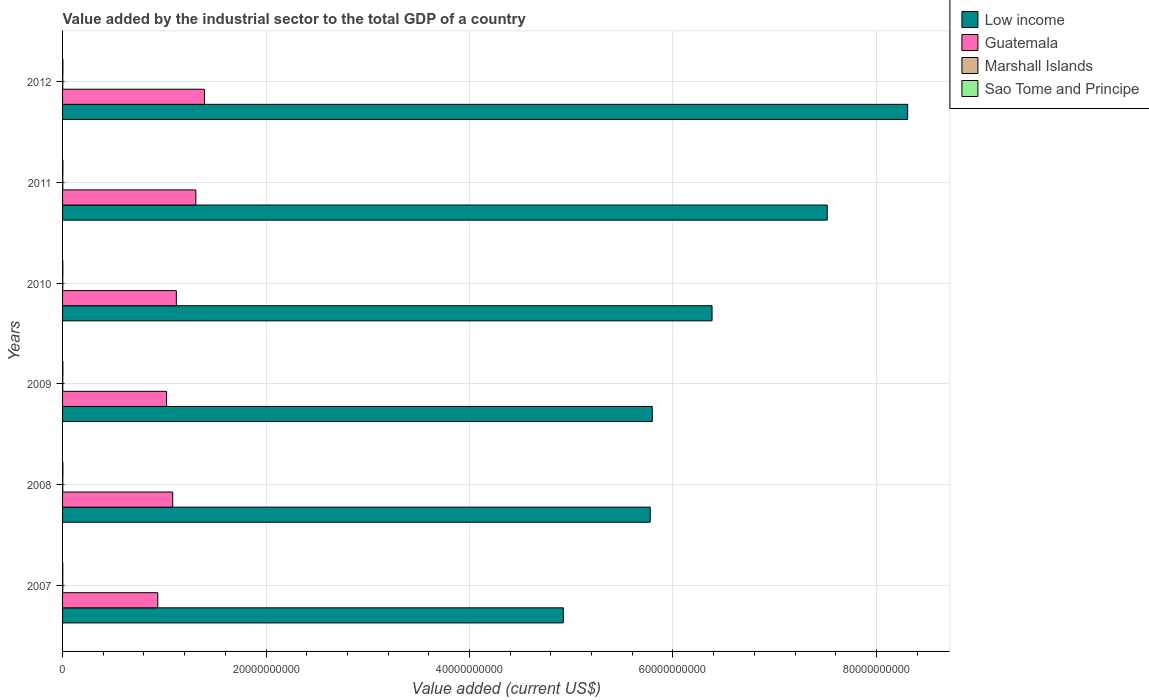How many groups of bars are there?
Your response must be concise. 6. Are the number of bars on each tick of the Y-axis equal?
Give a very brief answer. Yes. What is the label of the 6th group of bars from the top?
Offer a very short reply. 2007. In how many cases, is the number of bars for a given year not equal to the number of legend labels?
Your answer should be compact. 0. What is the value added by the industrial sector to the total GDP in Guatemala in 2007?
Make the answer very short. 9.36e+09. Across all years, what is the maximum value added by the industrial sector to the total GDP in Low income?
Your response must be concise. 8.31e+1. Across all years, what is the minimum value added by the industrial sector to the total GDP in Guatemala?
Provide a short and direct response. 9.36e+09. What is the total value added by the industrial sector to the total GDP in Marshall Islands in the graph?
Provide a succinct answer. 1.15e+08. What is the difference between the value added by the industrial sector to the total GDP in Low income in 2010 and that in 2011?
Make the answer very short. -1.13e+1. What is the difference between the value added by the industrial sector to the total GDP in Sao Tome and Principe in 2009 and the value added by the industrial sector to the total GDP in Marshall Islands in 2007?
Your answer should be compact. 1.25e+07. What is the average value added by the industrial sector to the total GDP in Low income per year?
Your response must be concise. 6.45e+1. In the year 2011, what is the difference between the value added by the industrial sector to the total GDP in Low income and value added by the industrial sector to the total GDP in Guatemala?
Ensure brevity in your answer.  6.21e+1. What is the ratio of the value added by the industrial sector to the total GDP in Marshall Islands in 2009 to that in 2011?
Your answer should be compact. 0.82. Is the value added by the industrial sector to the total GDP in Guatemala in 2008 less than that in 2009?
Your answer should be compact. No. What is the difference between the highest and the second highest value added by the industrial sector to the total GDP in Marshall Islands?
Offer a terse response. 1.68e+06. What is the difference between the highest and the lowest value added by the industrial sector to the total GDP in Marshall Islands?
Your answer should be very brief. 3.79e+06. What does the 1st bar from the top in 2009 represents?
Your answer should be compact. Sao Tome and Principe. Is it the case that in every year, the sum of the value added by the industrial sector to the total GDP in Marshall Islands and value added by the industrial sector to the total GDP in Low income is greater than the value added by the industrial sector to the total GDP in Guatemala?
Keep it short and to the point. Yes. How many bars are there?
Ensure brevity in your answer.  24. Are all the bars in the graph horizontal?
Provide a succinct answer. Yes. How many years are there in the graph?
Ensure brevity in your answer.  6. Does the graph contain any zero values?
Your response must be concise. No. Does the graph contain grids?
Your answer should be very brief. Yes. Where does the legend appear in the graph?
Offer a terse response. Top right. What is the title of the graph?
Make the answer very short. Value added by the industrial sector to the total GDP of a country. Does "Syrian Arab Republic" appear as one of the legend labels in the graph?
Your response must be concise. No. What is the label or title of the X-axis?
Give a very brief answer. Value added (current US$). What is the label or title of the Y-axis?
Give a very brief answer. Years. What is the Value added (current US$) in Low income in 2007?
Keep it short and to the point. 4.92e+1. What is the Value added (current US$) of Guatemala in 2007?
Ensure brevity in your answer.  9.36e+09. What is the Value added (current US$) of Marshall Islands in 2007?
Your response must be concise. 1.90e+07. What is the Value added (current US$) of Sao Tome and Principe in 2007?
Keep it short and to the point. 2.17e+07. What is the Value added (current US$) of Low income in 2008?
Ensure brevity in your answer.  5.78e+1. What is the Value added (current US$) of Guatemala in 2008?
Offer a terse response. 1.08e+1. What is the Value added (current US$) in Marshall Islands in 2008?
Your answer should be very brief. 1.95e+07. What is the Value added (current US$) of Sao Tome and Principe in 2008?
Your response must be concise. 3.22e+07. What is the Value added (current US$) in Low income in 2009?
Provide a succinct answer. 5.80e+1. What is the Value added (current US$) of Guatemala in 2009?
Make the answer very short. 1.02e+1. What is the Value added (current US$) in Marshall Islands in 2009?
Provide a short and direct response. 1.76e+07. What is the Value added (current US$) in Sao Tome and Principe in 2009?
Your answer should be very brief. 3.15e+07. What is the Value added (current US$) in Low income in 2010?
Your answer should be very brief. 6.38e+1. What is the Value added (current US$) in Guatemala in 2010?
Offer a very short reply. 1.12e+1. What is the Value added (current US$) in Marshall Islands in 2010?
Provide a succinct answer. 1.83e+07. What is the Value added (current US$) of Sao Tome and Principe in 2010?
Give a very brief answer. 2.71e+07. What is the Value added (current US$) of Low income in 2011?
Offer a very short reply. 7.52e+1. What is the Value added (current US$) of Guatemala in 2011?
Make the answer very short. 1.31e+1. What is the Value added (current US$) in Marshall Islands in 2011?
Offer a terse response. 2.13e+07. What is the Value added (current US$) of Sao Tome and Principe in 2011?
Make the answer very short. 3.18e+07. What is the Value added (current US$) in Low income in 2012?
Offer a very short reply. 8.31e+1. What is the Value added (current US$) in Guatemala in 2012?
Offer a terse response. 1.39e+1. What is the Value added (current US$) of Marshall Islands in 2012?
Offer a terse response. 1.97e+07. What is the Value added (current US$) in Sao Tome and Principe in 2012?
Offer a terse response. 3.20e+07. Across all years, what is the maximum Value added (current US$) in Low income?
Your answer should be compact. 8.31e+1. Across all years, what is the maximum Value added (current US$) in Guatemala?
Your answer should be compact. 1.39e+1. Across all years, what is the maximum Value added (current US$) in Marshall Islands?
Provide a short and direct response. 2.13e+07. Across all years, what is the maximum Value added (current US$) of Sao Tome and Principe?
Keep it short and to the point. 3.22e+07. Across all years, what is the minimum Value added (current US$) of Low income?
Your answer should be very brief. 4.92e+1. Across all years, what is the minimum Value added (current US$) in Guatemala?
Give a very brief answer. 9.36e+09. Across all years, what is the minimum Value added (current US$) of Marshall Islands?
Your answer should be very brief. 1.76e+07. Across all years, what is the minimum Value added (current US$) of Sao Tome and Principe?
Offer a very short reply. 2.17e+07. What is the total Value added (current US$) of Low income in the graph?
Provide a succinct answer. 3.87e+11. What is the total Value added (current US$) in Guatemala in the graph?
Ensure brevity in your answer.  6.86e+1. What is the total Value added (current US$) of Marshall Islands in the graph?
Give a very brief answer. 1.15e+08. What is the total Value added (current US$) in Sao Tome and Principe in the graph?
Your answer should be compact. 1.76e+08. What is the difference between the Value added (current US$) of Low income in 2007 and that in 2008?
Ensure brevity in your answer.  -8.54e+09. What is the difference between the Value added (current US$) in Guatemala in 2007 and that in 2008?
Give a very brief answer. -1.47e+09. What is the difference between the Value added (current US$) in Marshall Islands in 2007 and that in 2008?
Give a very brief answer. -4.33e+05. What is the difference between the Value added (current US$) in Sao Tome and Principe in 2007 and that in 2008?
Keep it short and to the point. -1.04e+07. What is the difference between the Value added (current US$) of Low income in 2007 and that in 2009?
Make the answer very short. -8.74e+09. What is the difference between the Value added (current US$) of Guatemala in 2007 and that in 2009?
Ensure brevity in your answer.  -8.59e+08. What is the difference between the Value added (current US$) of Marshall Islands in 2007 and that in 2009?
Provide a short and direct response. 1.47e+06. What is the difference between the Value added (current US$) in Sao Tome and Principe in 2007 and that in 2009?
Your answer should be very brief. -9.80e+06. What is the difference between the Value added (current US$) in Low income in 2007 and that in 2010?
Offer a terse response. -1.46e+1. What is the difference between the Value added (current US$) in Guatemala in 2007 and that in 2010?
Give a very brief answer. -1.82e+09. What is the difference between the Value added (current US$) in Marshall Islands in 2007 and that in 2010?
Make the answer very short. 7.64e+05. What is the difference between the Value added (current US$) in Sao Tome and Principe in 2007 and that in 2010?
Your response must be concise. -5.40e+06. What is the difference between the Value added (current US$) of Low income in 2007 and that in 2011?
Keep it short and to the point. -2.59e+1. What is the difference between the Value added (current US$) of Guatemala in 2007 and that in 2011?
Provide a succinct answer. -3.74e+09. What is the difference between the Value added (current US$) in Marshall Islands in 2007 and that in 2011?
Offer a very short reply. -2.33e+06. What is the difference between the Value added (current US$) in Sao Tome and Principe in 2007 and that in 2011?
Provide a short and direct response. -1.01e+07. What is the difference between the Value added (current US$) of Low income in 2007 and that in 2012?
Keep it short and to the point. -3.38e+1. What is the difference between the Value added (current US$) in Guatemala in 2007 and that in 2012?
Keep it short and to the point. -4.59e+09. What is the difference between the Value added (current US$) in Marshall Islands in 2007 and that in 2012?
Provide a short and direct response. -6.45e+05. What is the difference between the Value added (current US$) in Sao Tome and Principe in 2007 and that in 2012?
Provide a short and direct response. -1.03e+07. What is the difference between the Value added (current US$) of Low income in 2008 and that in 2009?
Provide a succinct answer. -2.02e+08. What is the difference between the Value added (current US$) in Guatemala in 2008 and that in 2009?
Offer a terse response. 6.07e+08. What is the difference between the Value added (current US$) of Marshall Islands in 2008 and that in 2009?
Your answer should be very brief. 1.90e+06. What is the difference between the Value added (current US$) of Sao Tome and Principe in 2008 and that in 2009?
Offer a very short reply. 6.39e+05. What is the difference between the Value added (current US$) in Low income in 2008 and that in 2010?
Your response must be concise. -6.08e+09. What is the difference between the Value added (current US$) of Guatemala in 2008 and that in 2010?
Your answer should be very brief. -3.57e+08. What is the difference between the Value added (current US$) in Marshall Islands in 2008 and that in 2010?
Ensure brevity in your answer.  1.20e+06. What is the difference between the Value added (current US$) in Sao Tome and Principe in 2008 and that in 2010?
Give a very brief answer. 5.04e+06. What is the difference between the Value added (current US$) of Low income in 2008 and that in 2011?
Ensure brevity in your answer.  -1.74e+1. What is the difference between the Value added (current US$) of Guatemala in 2008 and that in 2011?
Provide a short and direct response. -2.27e+09. What is the difference between the Value added (current US$) of Marshall Islands in 2008 and that in 2011?
Your answer should be compact. -1.89e+06. What is the difference between the Value added (current US$) in Sao Tome and Principe in 2008 and that in 2011?
Make the answer very short. 3.62e+05. What is the difference between the Value added (current US$) of Low income in 2008 and that in 2012?
Offer a very short reply. -2.53e+1. What is the difference between the Value added (current US$) in Guatemala in 2008 and that in 2012?
Your response must be concise. -3.12e+09. What is the difference between the Value added (current US$) in Marshall Islands in 2008 and that in 2012?
Keep it short and to the point. -2.12e+05. What is the difference between the Value added (current US$) of Sao Tome and Principe in 2008 and that in 2012?
Your answer should be compact. 1.68e+05. What is the difference between the Value added (current US$) of Low income in 2009 and that in 2010?
Give a very brief answer. -5.88e+09. What is the difference between the Value added (current US$) of Guatemala in 2009 and that in 2010?
Provide a short and direct response. -9.63e+08. What is the difference between the Value added (current US$) in Marshall Islands in 2009 and that in 2010?
Offer a terse response. -7.02e+05. What is the difference between the Value added (current US$) in Sao Tome and Principe in 2009 and that in 2010?
Your response must be concise. 4.40e+06. What is the difference between the Value added (current US$) of Low income in 2009 and that in 2011?
Provide a succinct answer. -1.72e+1. What is the difference between the Value added (current US$) of Guatemala in 2009 and that in 2011?
Give a very brief answer. -2.88e+09. What is the difference between the Value added (current US$) of Marshall Islands in 2009 and that in 2011?
Give a very brief answer. -3.79e+06. What is the difference between the Value added (current US$) in Sao Tome and Principe in 2009 and that in 2011?
Your answer should be very brief. -2.76e+05. What is the difference between the Value added (current US$) in Low income in 2009 and that in 2012?
Provide a succinct answer. -2.51e+1. What is the difference between the Value added (current US$) of Guatemala in 2009 and that in 2012?
Keep it short and to the point. -3.73e+09. What is the difference between the Value added (current US$) in Marshall Islands in 2009 and that in 2012?
Your answer should be very brief. -2.11e+06. What is the difference between the Value added (current US$) in Sao Tome and Principe in 2009 and that in 2012?
Ensure brevity in your answer.  -4.70e+05. What is the difference between the Value added (current US$) in Low income in 2010 and that in 2011?
Offer a very short reply. -1.13e+1. What is the difference between the Value added (current US$) of Guatemala in 2010 and that in 2011?
Give a very brief answer. -1.92e+09. What is the difference between the Value added (current US$) in Marshall Islands in 2010 and that in 2011?
Offer a very short reply. -3.09e+06. What is the difference between the Value added (current US$) in Sao Tome and Principe in 2010 and that in 2011?
Make the answer very short. -4.68e+06. What is the difference between the Value added (current US$) of Low income in 2010 and that in 2012?
Your response must be concise. -1.92e+1. What is the difference between the Value added (current US$) of Guatemala in 2010 and that in 2012?
Offer a very short reply. -2.76e+09. What is the difference between the Value added (current US$) in Marshall Islands in 2010 and that in 2012?
Offer a terse response. -1.41e+06. What is the difference between the Value added (current US$) of Sao Tome and Principe in 2010 and that in 2012?
Your response must be concise. -4.87e+06. What is the difference between the Value added (current US$) of Low income in 2011 and that in 2012?
Your answer should be compact. -7.90e+09. What is the difference between the Value added (current US$) in Guatemala in 2011 and that in 2012?
Keep it short and to the point. -8.49e+08. What is the difference between the Value added (current US$) in Marshall Islands in 2011 and that in 2012?
Give a very brief answer. 1.68e+06. What is the difference between the Value added (current US$) in Sao Tome and Principe in 2011 and that in 2012?
Make the answer very short. -1.94e+05. What is the difference between the Value added (current US$) in Low income in 2007 and the Value added (current US$) in Guatemala in 2008?
Your response must be concise. 3.84e+1. What is the difference between the Value added (current US$) in Low income in 2007 and the Value added (current US$) in Marshall Islands in 2008?
Make the answer very short. 4.92e+1. What is the difference between the Value added (current US$) of Low income in 2007 and the Value added (current US$) of Sao Tome and Principe in 2008?
Provide a succinct answer. 4.92e+1. What is the difference between the Value added (current US$) in Guatemala in 2007 and the Value added (current US$) in Marshall Islands in 2008?
Provide a short and direct response. 9.34e+09. What is the difference between the Value added (current US$) of Guatemala in 2007 and the Value added (current US$) of Sao Tome and Principe in 2008?
Offer a terse response. 9.33e+09. What is the difference between the Value added (current US$) in Marshall Islands in 2007 and the Value added (current US$) in Sao Tome and Principe in 2008?
Offer a very short reply. -1.32e+07. What is the difference between the Value added (current US$) of Low income in 2007 and the Value added (current US$) of Guatemala in 2009?
Provide a short and direct response. 3.90e+1. What is the difference between the Value added (current US$) of Low income in 2007 and the Value added (current US$) of Marshall Islands in 2009?
Keep it short and to the point. 4.92e+1. What is the difference between the Value added (current US$) of Low income in 2007 and the Value added (current US$) of Sao Tome and Principe in 2009?
Offer a very short reply. 4.92e+1. What is the difference between the Value added (current US$) of Guatemala in 2007 and the Value added (current US$) of Marshall Islands in 2009?
Offer a terse response. 9.34e+09. What is the difference between the Value added (current US$) of Guatemala in 2007 and the Value added (current US$) of Sao Tome and Principe in 2009?
Make the answer very short. 9.33e+09. What is the difference between the Value added (current US$) in Marshall Islands in 2007 and the Value added (current US$) in Sao Tome and Principe in 2009?
Provide a short and direct response. -1.25e+07. What is the difference between the Value added (current US$) in Low income in 2007 and the Value added (current US$) in Guatemala in 2010?
Give a very brief answer. 3.80e+1. What is the difference between the Value added (current US$) of Low income in 2007 and the Value added (current US$) of Marshall Islands in 2010?
Make the answer very short. 4.92e+1. What is the difference between the Value added (current US$) in Low income in 2007 and the Value added (current US$) in Sao Tome and Principe in 2010?
Offer a terse response. 4.92e+1. What is the difference between the Value added (current US$) in Guatemala in 2007 and the Value added (current US$) in Marshall Islands in 2010?
Your response must be concise. 9.34e+09. What is the difference between the Value added (current US$) in Guatemala in 2007 and the Value added (current US$) in Sao Tome and Principe in 2010?
Provide a succinct answer. 9.33e+09. What is the difference between the Value added (current US$) in Marshall Islands in 2007 and the Value added (current US$) in Sao Tome and Principe in 2010?
Your response must be concise. -8.12e+06. What is the difference between the Value added (current US$) in Low income in 2007 and the Value added (current US$) in Guatemala in 2011?
Keep it short and to the point. 3.61e+1. What is the difference between the Value added (current US$) in Low income in 2007 and the Value added (current US$) in Marshall Islands in 2011?
Make the answer very short. 4.92e+1. What is the difference between the Value added (current US$) of Low income in 2007 and the Value added (current US$) of Sao Tome and Principe in 2011?
Provide a short and direct response. 4.92e+1. What is the difference between the Value added (current US$) in Guatemala in 2007 and the Value added (current US$) in Marshall Islands in 2011?
Offer a terse response. 9.34e+09. What is the difference between the Value added (current US$) of Guatemala in 2007 and the Value added (current US$) of Sao Tome and Principe in 2011?
Your answer should be compact. 9.33e+09. What is the difference between the Value added (current US$) of Marshall Islands in 2007 and the Value added (current US$) of Sao Tome and Principe in 2011?
Your answer should be compact. -1.28e+07. What is the difference between the Value added (current US$) of Low income in 2007 and the Value added (current US$) of Guatemala in 2012?
Give a very brief answer. 3.53e+1. What is the difference between the Value added (current US$) in Low income in 2007 and the Value added (current US$) in Marshall Islands in 2012?
Offer a very short reply. 4.92e+1. What is the difference between the Value added (current US$) in Low income in 2007 and the Value added (current US$) in Sao Tome and Principe in 2012?
Provide a short and direct response. 4.92e+1. What is the difference between the Value added (current US$) of Guatemala in 2007 and the Value added (current US$) of Marshall Islands in 2012?
Offer a very short reply. 9.34e+09. What is the difference between the Value added (current US$) in Guatemala in 2007 and the Value added (current US$) in Sao Tome and Principe in 2012?
Offer a terse response. 9.33e+09. What is the difference between the Value added (current US$) of Marshall Islands in 2007 and the Value added (current US$) of Sao Tome and Principe in 2012?
Offer a very short reply. -1.30e+07. What is the difference between the Value added (current US$) of Low income in 2008 and the Value added (current US$) of Guatemala in 2009?
Offer a terse response. 4.75e+1. What is the difference between the Value added (current US$) in Low income in 2008 and the Value added (current US$) in Marshall Islands in 2009?
Your answer should be very brief. 5.77e+1. What is the difference between the Value added (current US$) in Low income in 2008 and the Value added (current US$) in Sao Tome and Principe in 2009?
Ensure brevity in your answer.  5.77e+1. What is the difference between the Value added (current US$) in Guatemala in 2008 and the Value added (current US$) in Marshall Islands in 2009?
Provide a succinct answer. 1.08e+1. What is the difference between the Value added (current US$) in Guatemala in 2008 and the Value added (current US$) in Sao Tome and Principe in 2009?
Keep it short and to the point. 1.08e+1. What is the difference between the Value added (current US$) in Marshall Islands in 2008 and the Value added (current US$) in Sao Tome and Principe in 2009?
Make the answer very short. -1.21e+07. What is the difference between the Value added (current US$) in Low income in 2008 and the Value added (current US$) in Guatemala in 2010?
Offer a very short reply. 4.66e+1. What is the difference between the Value added (current US$) of Low income in 2008 and the Value added (current US$) of Marshall Islands in 2010?
Offer a very short reply. 5.77e+1. What is the difference between the Value added (current US$) of Low income in 2008 and the Value added (current US$) of Sao Tome and Principe in 2010?
Offer a terse response. 5.77e+1. What is the difference between the Value added (current US$) in Guatemala in 2008 and the Value added (current US$) in Marshall Islands in 2010?
Your answer should be very brief. 1.08e+1. What is the difference between the Value added (current US$) of Guatemala in 2008 and the Value added (current US$) of Sao Tome and Principe in 2010?
Offer a very short reply. 1.08e+1. What is the difference between the Value added (current US$) of Marshall Islands in 2008 and the Value added (current US$) of Sao Tome and Principe in 2010?
Keep it short and to the point. -7.68e+06. What is the difference between the Value added (current US$) in Low income in 2008 and the Value added (current US$) in Guatemala in 2011?
Offer a terse response. 4.47e+1. What is the difference between the Value added (current US$) in Low income in 2008 and the Value added (current US$) in Marshall Islands in 2011?
Provide a short and direct response. 5.77e+1. What is the difference between the Value added (current US$) in Low income in 2008 and the Value added (current US$) in Sao Tome and Principe in 2011?
Your answer should be compact. 5.77e+1. What is the difference between the Value added (current US$) in Guatemala in 2008 and the Value added (current US$) in Marshall Islands in 2011?
Give a very brief answer. 1.08e+1. What is the difference between the Value added (current US$) of Guatemala in 2008 and the Value added (current US$) of Sao Tome and Principe in 2011?
Give a very brief answer. 1.08e+1. What is the difference between the Value added (current US$) in Marshall Islands in 2008 and the Value added (current US$) in Sao Tome and Principe in 2011?
Your response must be concise. -1.24e+07. What is the difference between the Value added (current US$) of Low income in 2008 and the Value added (current US$) of Guatemala in 2012?
Provide a short and direct response. 4.38e+1. What is the difference between the Value added (current US$) in Low income in 2008 and the Value added (current US$) in Marshall Islands in 2012?
Your answer should be compact. 5.77e+1. What is the difference between the Value added (current US$) in Low income in 2008 and the Value added (current US$) in Sao Tome and Principe in 2012?
Your answer should be very brief. 5.77e+1. What is the difference between the Value added (current US$) of Guatemala in 2008 and the Value added (current US$) of Marshall Islands in 2012?
Your answer should be very brief. 1.08e+1. What is the difference between the Value added (current US$) in Guatemala in 2008 and the Value added (current US$) in Sao Tome and Principe in 2012?
Offer a terse response. 1.08e+1. What is the difference between the Value added (current US$) of Marshall Islands in 2008 and the Value added (current US$) of Sao Tome and Principe in 2012?
Your response must be concise. -1.26e+07. What is the difference between the Value added (current US$) of Low income in 2009 and the Value added (current US$) of Guatemala in 2010?
Provide a succinct answer. 4.68e+1. What is the difference between the Value added (current US$) of Low income in 2009 and the Value added (current US$) of Marshall Islands in 2010?
Your answer should be very brief. 5.79e+1. What is the difference between the Value added (current US$) in Low income in 2009 and the Value added (current US$) in Sao Tome and Principe in 2010?
Give a very brief answer. 5.79e+1. What is the difference between the Value added (current US$) of Guatemala in 2009 and the Value added (current US$) of Marshall Islands in 2010?
Your answer should be compact. 1.02e+1. What is the difference between the Value added (current US$) of Guatemala in 2009 and the Value added (current US$) of Sao Tome and Principe in 2010?
Provide a short and direct response. 1.02e+1. What is the difference between the Value added (current US$) of Marshall Islands in 2009 and the Value added (current US$) of Sao Tome and Principe in 2010?
Your answer should be compact. -9.58e+06. What is the difference between the Value added (current US$) of Low income in 2009 and the Value added (current US$) of Guatemala in 2011?
Make the answer very short. 4.49e+1. What is the difference between the Value added (current US$) in Low income in 2009 and the Value added (current US$) in Marshall Islands in 2011?
Your answer should be very brief. 5.79e+1. What is the difference between the Value added (current US$) in Low income in 2009 and the Value added (current US$) in Sao Tome and Principe in 2011?
Your answer should be compact. 5.79e+1. What is the difference between the Value added (current US$) in Guatemala in 2009 and the Value added (current US$) in Marshall Islands in 2011?
Provide a short and direct response. 1.02e+1. What is the difference between the Value added (current US$) of Guatemala in 2009 and the Value added (current US$) of Sao Tome and Principe in 2011?
Make the answer very short. 1.02e+1. What is the difference between the Value added (current US$) of Marshall Islands in 2009 and the Value added (current US$) of Sao Tome and Principe in 2011?
Provide a succinct answer. -1.43e+07. What is the difference between the Value added (current US$) in Low income in 2009 and the Value added (current US$) in Guatemala in 2012?
Your answer should be very brief. 4.40e+1. What is the difference between the Value added (current US$) in Low income in 2009 and the Value added (current US$) in Marshall Islands in 2012?
Ensure brevity in your answer.  5.79e+1. What is the difference between the Value added (current US$) in Low income in 2009 and the Value added (current US$) in Sao Tome and Principe in 2012?
Your answer should be compact. 5.79e+1. What is the difference between the Value added (current US$) of Guatemala in 2009 and the Value added (current US$) of Marshall Islands in 2012?
Offer a terse response. 1.02e+1. What is the difference between the Value added (current US$) in Guatemala in 2009 and the Value added (current US$) in Sao Tome and Principe in 2012?
Your answer should be very brief. 1.02e+1. What is the difference between the Value added (current US$) of Marshall Islands in 2009 and the Value added (current US$) of Sao Tome and Principe in 2012?
Offer a terse response. -1.45e+07. What is the difference between the Value added (current US$) in Low income in 2010 and the Value added (current US$) in Guatemala in 2011?
Ensure brevity in your answer.  5.07e+1. What is the difference between the Value added (current US$) of Low income in 2010 and the Value added (current US$) of Marshall Islands in 2011?
Give a very brief answer. 6.38e+1. What is the difference between the Value added (current US$) of Low income in 2010 and the Value added (current US$) of Sao Tome and Principe in 2011?
Your response must be concise. 6.38e+1. What is the difference between the Value added (current US$) in Guatemala in 2010 and the Value added (current US$) in Marshall Islands in 2011?
Keep it short and to the point. 1.12e+1. What is the difference between the Value added (current US$) in Guatemala in 2010 and the Value added (current US$) in Sao Tome and Principe in 2011?
Provide a succinct answer. 1.12e+1. What is the difference between the Value added (current US$) in Marshall Islands in 2010 and the Value added (current US$) in Sao Tome and Principe in 2011?
Offer a very short reply. -1.36e+07. What is the difference between the Value added (current US$) of Low income in 2010 and the Value added (current US$) of Guatemala in 2012?
Offer a terse response. 4.99e+1. What is the difference between the Value added (current US$) of Low income in 2010 and the Value added (current US$) of Marshall Islands in 2012?
Your answer should be very brief. 6.38e+1. What is the difference between the Value added (current US$) of Low income in 2010 and the Value added (current US$) of Sao Tome and Principe in 2012?
Offer a terse response. 6.38e+1. What is the difference between the Value added (current US$) of Guatemala in 2010 and the Value added (current US$) of Marshall Islands in 2012?
Your answer should be compact. 1.12e+1. What is the difference between the Value added (current US$) in Guatemala in 2010 and the Value added (current US$) in Sao Tome and Principe in 2012?
Provide a succinct answer. 1.12e+1. What is the difference between the Value added (current US$) of Marshall Islands in 2010 and the Value added (current US$) of Sao Tome and Principe in 2012?
Provide a succinct answer. -1.38e+07. What is the difference between the Value added (current US$) of Low income in 2011 and the Value added (current US$) of Guatemala in 2012?
Your response must be concise. 6.12e+1. What is the difference between the Value added (current US$) in Low income in 2011 and the Value added (current US$) in Marshall Islands in 2012?
Offer a terse response. 7.51e+1. What is the difference between the Value added (current US$) of Low income in 2011 and the Value added (current US$) of Sao Tome and Principe in 2012?
Provide a succinct answer. 7.51e+1. What is the difference between the Value added (current US$) in Guatemala in 2011 and the Value added (current US$) in Marshall Islands in 2012?
Your response must be concise. 1.31e+1. What is the difference between the Value added (current US$) in Guatemala in 2011 and the Value added (current US$) in Sao Tome and Principe in 2012?
Offer a very short reply. 1.31e+1. What is the difference between the Value added (current US$) in Marshall Islands in 2011 and the Value added (current US$) in Sao Tome and Principe in 2012?
Provide a short and direct response. -1.07e+07. What is the average Value added (current US$) of Low income per year?
Provide a succinct answer. 6.45e+1. What is the average Value added (current US$) of Guatemala per year?
Offer a very short reply. 1.14e+1. What is the average Value added (current US$) in Marshall Islands per year?
Offer a terse response. 1.92e+07. What is the average Value added (current US$) of Sao Tome and Principe per year?
Your answer should be very brief. 2.94e+07. In the year 2007, what is the difference between the Value added (current US$) of Low income and Value added (current US$) of Guatemala?
Offer a terse response. 3.99e+1. In the year 2007, what is the difference between the Value added (current US$) of Low income and Value added (current US$) of Marshall Islands?
Make the answer very short. 4.92e+1. In the year 2007, what is the difference between the Value added (current US$) of Low income and Value added (current US$) of Sao Tome and Principe?
Ensure brevity in your answer.  4.92e+1. In the year 2007, what is the difference between the Value added (current US$) of Guatemala and Value added (current US$) of Marshall Islands?
Your response must be concise. 9.34e+09. In the year 2007, what is the difference between the Value added (current US$) in Guatemala and Value added (current US$) in Sao Tome and Principe?
Offer a very short reply. 9.34e+09. In the year 2007, what is the difference between the Value added (current US$) in Marshall Islands and Value added (current US$) in Sao Tome and Principe?
Offer a terse response. -2.71e+06. In the year 2008, what is the difference between the Value added (current US$) of Low income and Value added (current US$) of Guatemala?
Keep it short and to the point. 4.69e+1. In the year 2008, what is the difference between the Value added (current US$) of Low income and Value added (current US$) of Marshall Islands?
Your response must be concise. 5.77e+1. In the year 2008, what is the difference between the Value added (current US$) in Low income and Value added (current US$) in Sao Tome and Principe?
Keep it short and to the point. 5.77e+1. In the year 2008, what is the difference between the Value added (current US$) in Guatemala and Value added (current US$) in Marshall Islands?
Give a very brief answer. 1.08e+1. In the year 2008, what is the difference between the Value added (current US$) of Guatemala and Value added (current US$) of Sao Tome and Principe?
Your answer should be compact. 1.08e+1. In the year 2008, what is the difference between the Value added (current US$) in Marshall Islands and Value added (current US$) in Sao Tome and Principe?
Offer a terse response. -1.27e+07. In the year 2009, what is the difference between the Value added (current US$) of Low income and Value added (current US$) of Guatemala?
Your answer should be compact. 4.77e+1. In the year 2009, what is the difference between the Value added (current US$) of Low income and Value added (current US$) of Marshall Islands?
Offer a very short reply. 5.79e+1. In the year 2009, what is the difference between the Value added (current US$) in Low income and Value added (current US$) in Sao Tome and Principe?
Keep it short and to the point. 5.79e+1. In the year 2009, what is the difference between the Value added (current US$) in Guatemala and Value added (current US$) in Marshall Islands?
Make the answer very short. 1.02e+1. In the year 2009, what is the difference between the Value added (current US$) in Guatemala and Value added (current US$) in Sao Tome and Principe?
Offer a terse response. 1.02e+1. In the year 2009, what is the difference between the Value added (current US$) in Marshall Islands and Value added (current US$) in Sao Tome and Principe?
Offer a terse response. -1.40e+07. In the year 2010, what is the difference between the Value added (current US$) in Low income and Value added (current US$) in Guatemala?
Provide a succinct answer. 5.27e+1. In the year 2010, what is the difference between the Value added (current US$) of Low income and Value added (current US$) of Marshall Islands?
Ensure brevity in your answer.  6.38e+1. In the year 2010, what is the difference between the Value added (current US$) in Low income and Value added (current US$) in Sao Tome and Principe?
Your response must be concise. 6.38e+1. In the year 2010, what is the difference between the Value added (current US$) in Guatemala and Value added (current US$) in Marshall Islands?
Your response must be concise. 1.12e+1. In the year 2010, what is the difference between the Value added (current US$) in Guatemala and Value added (current US$) in Sao Tome and Principe?
Provide a short and direct response. 1.12e+1. In the year 2010, what is the difference between the Value added (current US$) of Marshall Islands and Value added (current US$) of Sao Tome and Principe?
Give a very brief answer. -8.88e+06. In the year 2011, what is the difference between the Value added (current US$) in Low income and Value added (current US$) in Guatemala?
Keep it short and to the point. 6.21e+1. In the year 2011, what is the difference between the Value added (current US$) of Low income and Value added (current US$) of Marshall Islands?
Make the answer very short. 7.51e+1. In the year 2011, what is the difference between the Value added (current US$) of Low income and Value added (current US$) of Sao Tome and Principe?
Give a very brief answer. 7.51e+1. In the year 2011, what is the difference between the Value added (current US$) in Guatemala and Value added (current US$) in Marshall Islands?
Give a very brief answer. 1.31e+1. In the year 2011, what is the difference between the Value added (current US$) in Guatemala and Value added (current US$) in Sao Tome and Principe?
Your answer should be compact. 1.31e+1. In the year 2011, what is the difference between the Value added (current US$) of Marshall Islands and Value added (current US$) of Sao Tome and Principe?
Give a very brief answer. -1.05e+07. In the year 2012, what is the difference between the Value added (current US$) of Low income and Value added (current US$) of Guatemala?
Ensure brevity in your answer.  6.91e+1. In the year 2012, what is the difference between the Value added (current US$) of Low income and Value added (current US$) of Marshall Islands?
Offer a very short reply. 8.31e+1. In the year 2012, what is the difference between the Value added (current US$) in Low income and Value added (current US$) in Sao Tome and Principe?
Ensure brevity in your answer.  8.30e+1. In the year 2012, what is the difference between the Value added (current US$) in Guatemala and Value added (current US$) in Marshall Islands?
Give a very brief answer. 1.39e+1. In the year 2012, what is the difference between the Value added (current US$) of Guatemala and Value added (current US$) of Sao Tome and Principe?
Offer a very short reply. 1.39e+1. In the year 2012, what is the difference between the Value added (current US$) of Marshall Islands and Value added (current US$) of Sao Tome and Principe?
Ensure brevity in your answer.  -1.23e+07. What is the ratio of the Value added (current US$) in Low income in 2007 to that in 2008?
Your response must be concise. 0.85. What is the ratio of the Value added (current US$) in Guatemala in 2007 to that in 2008?
Your response must be concise. 0.86. What is the ratio of the Value added (current US$) of Marshall Islands in 2007 to that in 2008?
Offer a terse response. 0.98. What is the ratio of the Value added (current US$) of Sao Tome and Principe in 2007 to that in 2008?
Your response must be concise. 0.68. What is the ratio of the Value added (current US$) of Low income in 2007 to that in 2009?
Keep it short and to the point. 0.85. What is the ratio of the Value added (current US$) of Guatemala in 2007 to that in 2009?
Offer a very short reply. 0.92. What is the ratio of the Value added (current US$) of Marshall Islands in 2007 to that in 2009?
Keep it short and to the point. 1.08. What is the ratio of the Value added (current US$) of Sao Tome and Principe in 2007 to that in 2009?
Your answer should be compact. 0.69. What is the ratio of the Value added (current US$) of Low income in 2007 to that in 2010?
Keep it short and to the point. 0.77. What is the ratio of the Value added (current US$) in Guatemala in 2007 to that in 2010?
Make the answer very short. 0.84. What is the ratio of the Value added (current US$) of Marshall Islands in 2007 to that in 2010?
Your answer should be compact. 1.04. What is the ratio of the Value added (current US$) in Sao Tome and Principe in 2007 to that in 2010?
Give a very brief answer. 0.8. What is the ratio of the Value added (current US$) in Low income in 2007 to that in 2011?
Your response must be concise. 0.65. What is the ratio of the Value added (current US$) of Guatemala in 2007 to that in 2011?
Provide a succinct answer. 0.71. What is the ratio of the Value added (current US$) in Marshall Islands in 2007 to that in 2011?
Provide a succinct answer. 0.89. What is the ratio of the Value added (current US$) of Sao Tome and Principe in 2007 to that in 2011?
Keep it short and to the point. 0.68. What is the ratio of the Value added (current US$) of Low income in 2007 to that in 2012?
Provide a short and direct response. 0.59. What is the ratio of the Value added (current US$) in Guatemala in 2007 to that in 2012?
Provide a succinct answer. 0.67. What is the ratio of the Value added (current US$) of Marshall Islands in 2007 to that in 2012?
Provide a short and direct response. 0.97. What is the ratio of the Value added (current US$) in Sao Tome and Principe in 2007 to that in 2012?
Your answer should be compact. 0.68. What is the ratio of the Value added (current US$) of Low income in 2008 to that in 2009?
Your response must be concise. 1. What is the ratio of the Value added (current US$) in Guatemala in 2008 to that in 2009?
Your response must be concise. 1.06. What is the ratio of the Value added (current US$) of Marshall Islands in 2008 to that in 2009?
Your answer should be compact. 1.11. What is the ratio of the Value added (current US$) of Sao Tome and Principe in 2008 to that in 2009?
Ensure brevity in your answer.  1.02. What is the ratio of the Value added (current US$) in Low income in 2008 to that in 2010?
Offer a very short reply. 0.9. What is the ratio of the Value added (current US$) in Guatemala in 2008 to that in 2010?
Your response must be concise. 0.97. What is the ratio of the Value added (current US$) of Marshall Islands in 2008 to that in 2010?
Your answer should be very brief. 1.07. What is the ratio of the Value added (current US$) of Sao Tome and Principe in 2008 to that in 2010?
Make the answer very short. 1.19. What is the ratio of the Value added (current US$) in Low income in 2008 to that in 2011?
Your answer should be very brief. 0.77. What is the ratio of the Value added (current US$) of Guatemala in 2008 to that in 2011?
Offer a very short reply. 0.83. What is the ratio of the Value added (current US$) in Marshall Islands in 2008 to that in 2011?
Ensure brevity in your answer.  0.91. What is the ratio of the Value added (current US$) in Sao Tome and Principe in 2008 to that in 2011?
Offer a very short reply. 1.01. What is the ratio of the Value added (current US$) of Low income in 2008 to that in 2012?
Make the answer very short. 0.7. What is the ratio of the Value added (current US$) of Guatemala in 2008 to that in 2012?
Make the answer very short. 0.78. What is the ratio of the Value added (current US$) in Marshall Islands in 2008 to that in 2012?
Make the answer very short. 0.99. What is the ratio of the Value added (current US$) of Low income in 2009 to that in 2010?
Your answer should be very brief. 0.91. What is the ratio of the Value added (current US$) of Guatemala in 2009 to that in 2010?
Provide a short and direct response. 0.91. What is the ratio of the Value added (current US$) in Marshall Islands in 2009 to that in 2010?
Provide a short and direct response. 0.96. What is the ratio of the Value added (current US$) of Sao Tome and Principe in 2009 to that in 2010?
Provide a succinct answer. 1.16. What is the ratio of the Value added (current US$) of Low income in 2009 to that in 2011?
Keep it short and to the point. 0.77. What is the ratio of the Value added (current US$) of Guatemala in 2009 to that in 2011?
Provide a short and direct response. 0.78. What is the ratio of the Value added (current US$) of Marshall Islands in 2009 to that in 2011?
Offer a very short reply. 0.82. What is the ratio of the Value added (current US$) in Sao Tome and Principe in 2009 to that in 2011?
Keep it short and to the point. 0.99. What is the ratio of the Value added (current US$) of Low income in 2009 to that in 2012?
Give a very brief answer. 0.7. What is the ratio of the Value added (current US$) of Guatemala in 2009 to that in 2012?
Keep it short and to the point. 0.73. What is the ratio of the Value added (current US$) of Marshall Islands in 2009 to that in 2012?
Your response must be concise. 0.89. What is the ratio of the Value added (current US$) in Sao Tome and Principe in 2009 to that in 2012?
Keep it short and to the point. 0.99. What is the ratio of the Value added (current US$) of Low income in 2010 to that in 2011?
Offer a very short reply. 0.85. What is the ratio of the Value added (current US$) in Guatemala in 2010 to that in 2011?
Offer a terse response. 0.85. What is the ratio of the Value added (current US$) in Marshall Islands in 2010 to that in 2011?
Provide a succinct answer. 0.86. What is the ratio of the Value added (current US$) of Sao Tome and Principe in 2010 to that in 2011?
Provide a succinct answer. 0.85. What is the ratio of the Value added (current US$) of Low income in 2010 to that in 2012?
Give a very brief answer. 0.77. What is the ratio of the Value added (current US$) in Guatemala in 2010 to that in 2012?
Offer a very short reply. 0.8. What is the ratio of the Value added (current US$) of Marshall Islands in 2010 to that in 2012?
Your answer should be compact. 0.93. What is the ratio of the Value added (current US$) of Sao Tome and Principe in 2010 to that in 2012?
Keep it short and to the point. 0.85. What is the ratio of the Value added (current US$) in Low income in 2011 to that in 2012?
Your answer should be very brief. 0.9. What is the ratio of the Value added (current US$) of Guatemala in 2011 to that in 2012?
Your answer should be very brief. 0.94. What is the ratio of the Value added (current US$) in Marshall Islands in 2011 to that in 2012?
Your response must be concise. 1.09. What is the difference between the highest and the second highest Value added (current US$) in Low income?
Offer a very short reply. 7.90e+09. What is the difference between the highest and the second highest Value added (current US$) of Guatemala?
Your answer should be compact. 8.49e+08. What is the difference between the highest and the second highest Value added (current US$) of Marshall Islands?
Make the answer very short. 1.68e+06. What is the difference between the highest and the second highest Value added (current US$) of Sao Tome and Principe?
Give a very brief answer. 1.68e+05. What is the difference between the highest and the lowest Value added (current US$) in Low income?
Provide a succinct answer. 3.38e+1. What is the difference between the highest and the lowest Value added (current US$) in Guatemala?
Ensure brevity in your answer.  4.59e+09. What is the difference between the highest and the lowest Value added (current US$) of Marshall Islands?
Offer a terse response. 3.79e+06. What is the difference between the highest and the lowest Value added (current US$) in Sao Tome and Principe?
Offer a very short reply. 1.04e+07. 